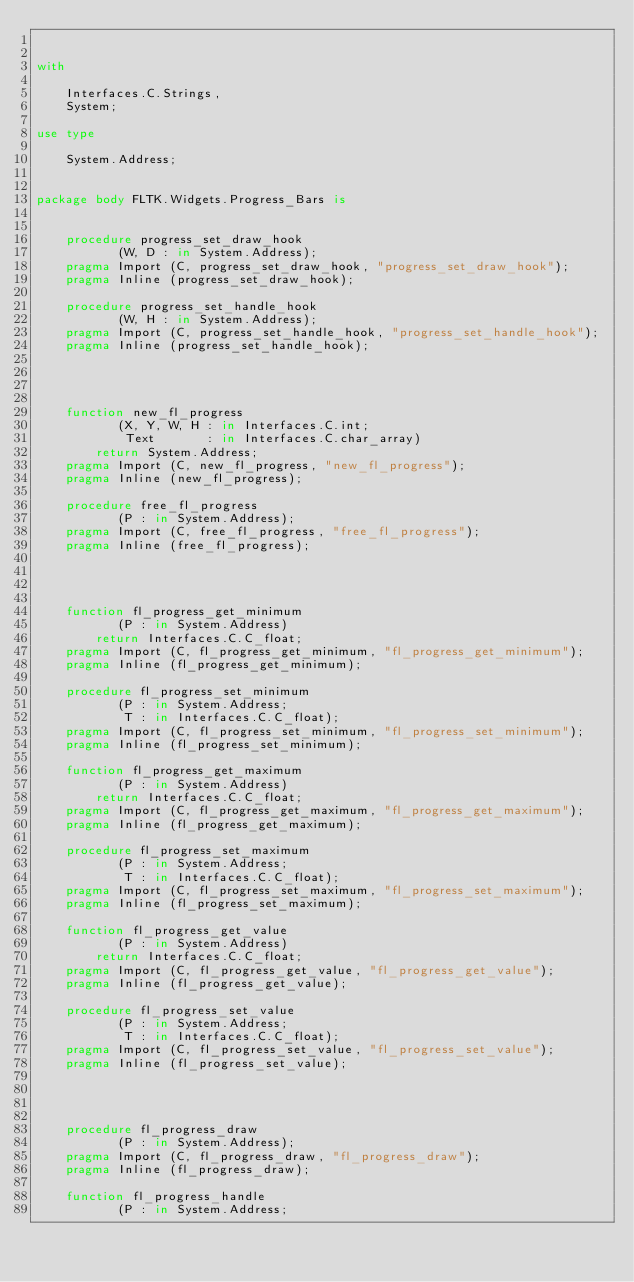Convert code to text. <code><loc_0><loc_0><loc_500><loc_500><_Ada_>

with

    Interfaces.C.Strings,
    System;

use type

    System.Address;


package body FLTK.Widgets.Progress_Bars is


    procedure progress_set_draw_hook
           (W, D : in System.Address);
    pragma Import (C, progress_set_draw_hook, "progress_set_draw_hook");
    pragma Inline (progress_set_draw_hook);

    procedure progress_set_handle_hook
           (W, H : in System.Address);
    pragma Import (C, progress_set_handle_hook, "progress_set_handle_hook");
    pragma Inline (progress_set_handle_hook);




    function new_fl_progress
           (X, Y, W, H : in Interfaces.C.int;
            Text       : in Interfaces.C.char_array)
        return System.Address;
    pragma Import (C, new_fl_progress, "new_fl_progress");
    pragma Inline (new_fl_progress);

    procedure free_fl_progress
           (P : in System.Address);
    pragma Import (C, free_fl_progress, "free_fl_progress");
    pragma Inline (free_fl_progress);




    function fl_progress_get_minimum
           (P : in System.Address)
        return Interfaces.C.C_float;
    pragma Import (C, fl_progress_get_minimum, "fl_progress_get_minimum");
    pragma Inline (fl_progress_get_minimum);

    procedure fl_progress_set_minimum
           (P : in System.Address;
            T : in Interfaces.C.C_float);
    pragma Import (C, fl_progress_set_minimum, "fl_progress_set_minimum");
    pragma Inline (fl_progress_set_minimum);

    function fl_progress_get_maximum
           (P : in System.Address)
        return Interfaces.C.C_float;
    pragma Import (C, fl_progress_get_maximum, "fl_progress_get_maximum");
    pragma Inline (fl_progress_get_maximum);

    procedure fl_progress_set_maximum
           (P : in System.Address;
            T : in Interfaces.C.C_float);
    pragma Import (C, fl_progress_set_maximum, "fl_progress_set_maximum");
    pragma Inline (fl_progress_set_maximum);

    function fl_progress_get_value
           (P : in System.Address)
        return Interfaces.C.C_float;
    pragma Import (C, fl_progress_get_value, "fl_progress_get_value");
    pragma Inline (fl_progress_get_value);

    procedure fl_progress_set_value
           (P : in System.Address;
            T : in Interfaces.C.C_float);
    pragma Import (C, fl_progress_set_value, "fl_progress_set_value");
    pragma Inline (fl_progress_set_value);




    procedure fl_progress_draw
           (P : in System.Address);
    pragma Import (C, fl_progress_draw, "fl_progress_draw");
    pragma Inline (fl_progress_draw);

    function fl_progress_handle
           (P : in System.Address;</code> 